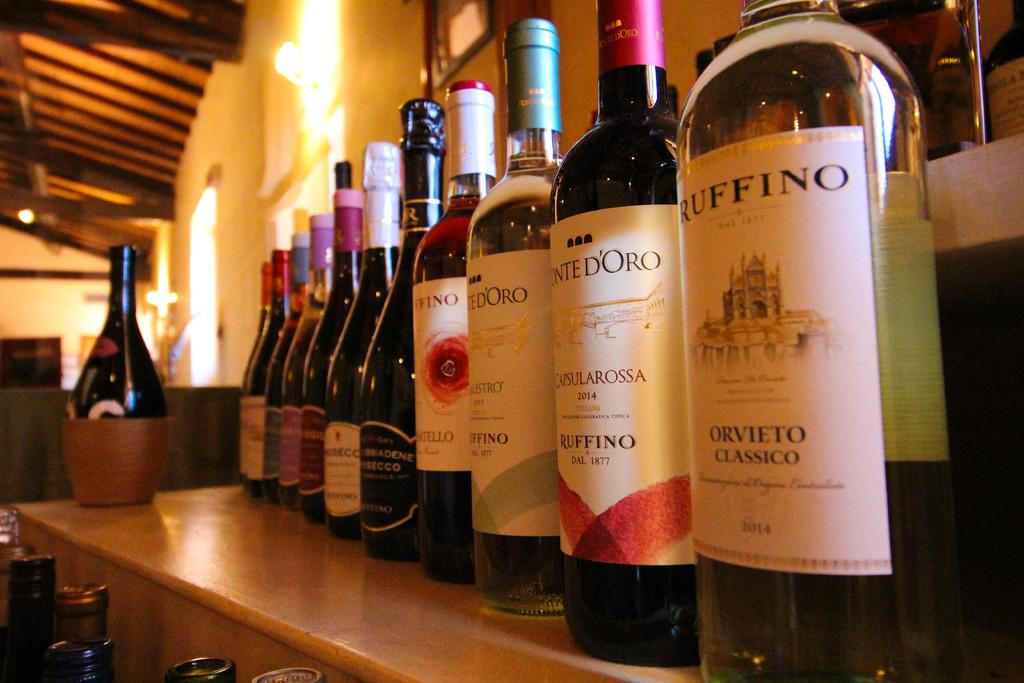<image>
Create a compact narrative representing the image presented. Bottles next to one another saying "Orvieto Classico" on the label. 